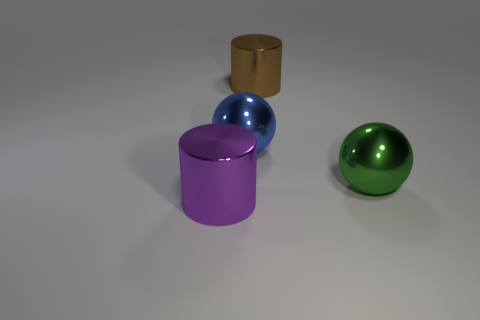Add 1 tiny matte cylinders. How many objects exist? 5 Subtract 1 balls. How many balls are left? 1 Subtract all shiny things. Subtract all large gray matte cylinders. How many objects are left? 0 Add 1 large purple metallic cylinders. How many large purple metallic cylinders are left? 2 Add 1 large brown objects. How many large brown objects exist? 2 Subtract 0 blue cylinders. How many objects are left? 4 Subtract all blue balls. Subtract all brown cubes. How many balls are left? 1 